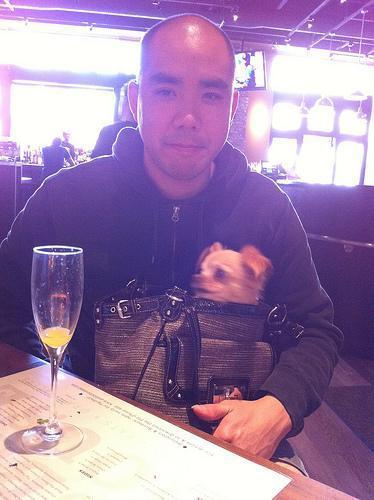How many dogs are pictured?
Give a very brief answer. 1. 